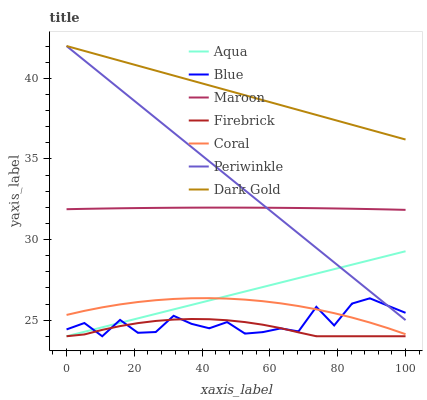Does Dark Gold have the minimum area under the curve?
Answer yes or no. No. Does Firebrick have the maximum area under the curve?
Answer yes or no. No. Is Firebrick the smoothest?
Answer yes or no. No. Is Firebrick the roughest?
Answer yes or no. No. Does Dark Gold have the lowest value?
Answer yes or no. No. Does Firebrick have the highest value?
Answer yes or no. No. Is Aqua less than Maroon?
Answer yes or no. Yes. Is Maroon greater than Firebrick?
Answer yes or no. Yes. Does Aqua intersect Maroon?
Answer yes or no. No. 